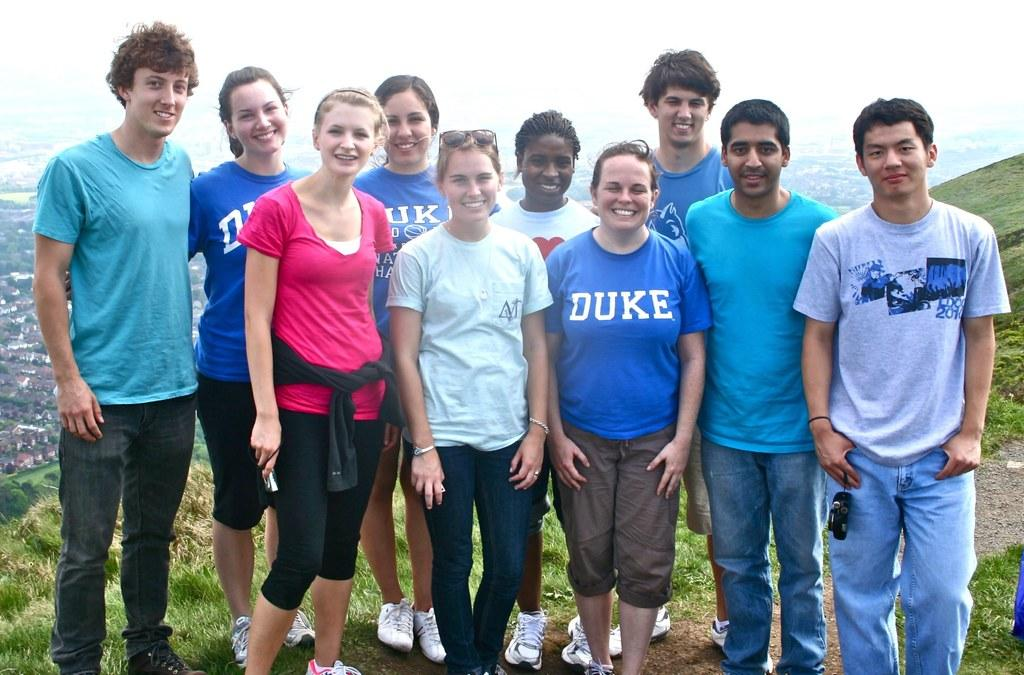What types of people are present in the image? There are men and women standing on the ground in the image. What can be seen in the distance behind the people? There are buildings, trees, hills, and the sky visible in the background of the image. What type of jewel is being used to keep track of time in the image? There is no jewel or timekeeping device present in the image. 